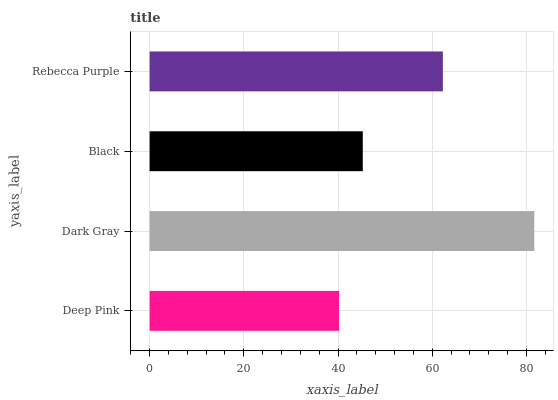Is Deep Pink the minimum?
Answer yes or no. Yes. Is Dark Gray the maximum?
Answer yes or no. Yes. Is Black the minimum?
Answer yes or no. No. Is Black the maximum?
Answer yes or no. No. Is Dark Gray greater than Black?
Answer yes or no. Yes. Is Black less than Dark Gray?
Answer yes or no. Yes. Is Black greater than Dark Gray?
Answer yes or no. No. Is Dark Gray less than Black?
Answer yes or no. No. Is Rebecca Purple the high median?
Answer yes or no. Yes. Is Black the low median?
Answer yes or no. Yes. Is Deep Pink the high median?
Answer yes or no. No. Is Deep Pink the low median?
Answer yes or no. No. 